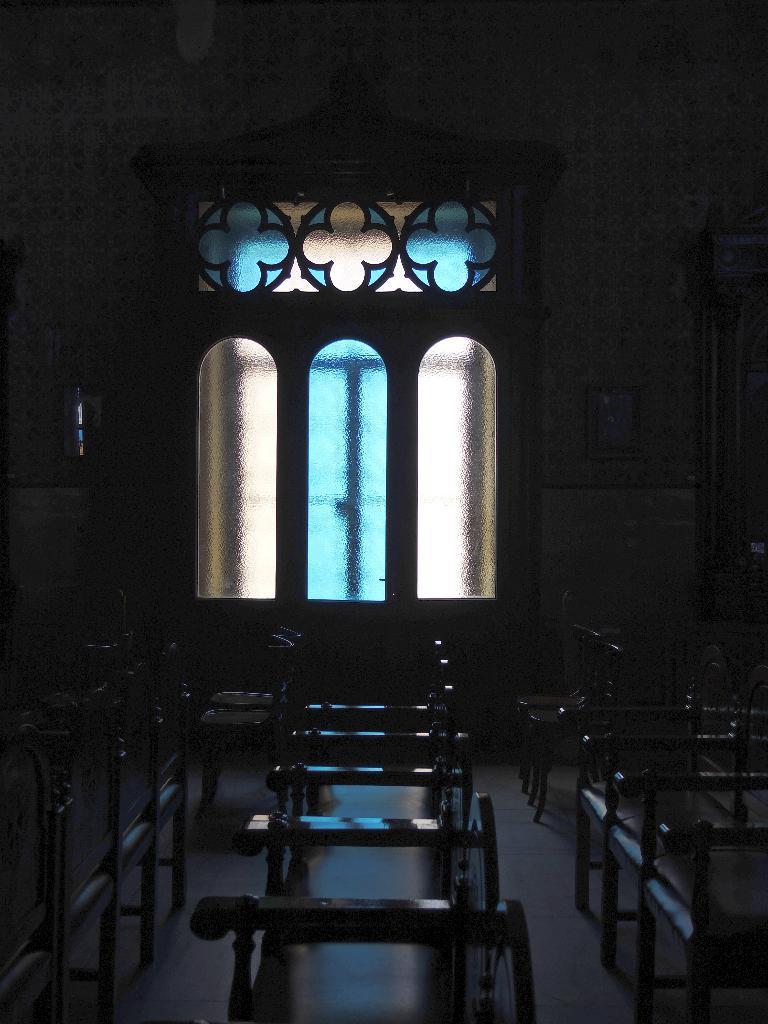Could you give a brief overview of what you see in this image? In this image we can see many chairs. In the back there is a window with glass. Also there is a wall. 